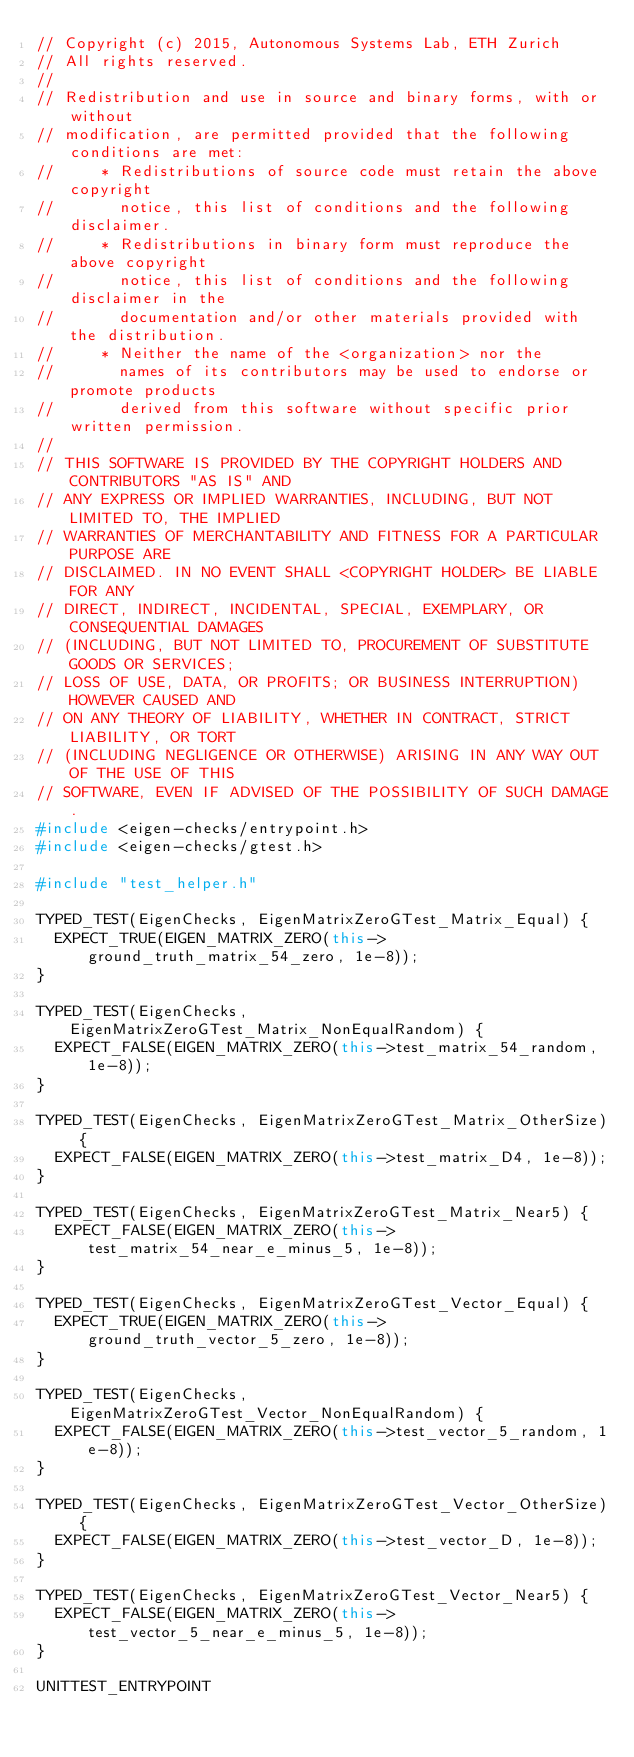Convert code to text. <code><loc_0><loc_0><loc_500><loc_500><_C++_>// Copyright (c) 2015, Autonomous Systems Lab, ETH Zurich
// All rights reserved.
//
// Redistribution and use in source and binary forms, with or without
// modification, are permitted provided that the following conditions are met:
//     * Redistributions of source code must retain the above copyright
//       notice, this list of conditions and the following disclaimer.
//     * Redistributions in binary form must reproduce the above copyright
//       notice, this list of conditions and the following disclaimer in the
//       documentation and/or other materials provided with the distribution.
//     * Neither the name of the <organization> nor the
//       names of its contributors may be used to endorse or promote products
//       derived from this software without specific prior written permission.
//
// THIS SOFTWARE IS PROVIDED BY THE COPYRIGHT HOLDERS AND CONTRIBUTORS "AS IS" AND
// ANY EXPRESS OR IMPLIED WARRANTIES, INCLUDING, BUT NOT LIMITED TO, THE IMPLIED
// WARRANTIES OF MERCHANTABILITY AND FITNESS FOR A PARTICULAR PURPOSE ARE
// DISCLAIMED. IN NO EVENT SHALL <COPYRIGHT HOLDER> BE LIABLE FOR ANY
// DIRECT, INDIRECT, INCIDENTAL, SPECIAL, EXEMPLARY, OR CONSEQUENTIAL DAMAGES
// (INCLUDING, BUT NOT LIMITED TO, PROCUREMENT OF SUBSTITUTE GOODS OR SERVICES;
// LOSS OF USE, DATA, OR PROFITS; OR BUSINESS INTERRUPTION) HOWEVER CAUSED AND
// ON ANY THEORY OF LIABILITY, WHETHER IN CONTRACT, STRICT LIABILITY, OR TORT
// (INCLUDING NEGLIGENCE OR OTHERWISE) ARISING IN ANY WAY OUT OF THE USE OF THIS
// SOFTWARE, EVEN IF ADVISED OF THE POSSIBILITY OF SUCH DAMAGE.
#include <eigen-checks/entrypoint.h>
#include <eigen-checks/gtest.h>

#include "test_helper.h"

TYPED_TEST(EigenChecks, EigenMatrixZeroGTest_Matrix_Equal) {
  EXPECT_TRUE(EIGEN_MATRIX_ZERO(this->ground_truth_matrix_54_zero, 1e-8));
}

TYPED_TEST(EigenChecks, EigenMatrixZeroGTest_Matrix_NonEqualRandom) {
  EXPECT_FALSE(EIGEN_MATRIX_ZERO(this->test_matrix_54_random, 1e-8));
}

TYPED_TEST(EigenChecks, EigenMatrixZeroGTest_Matrix_OtherSize) {
  EXPECT_FALSE(EIGEN_MATRIX_ZERO(this->test_matrix_D4, 1e-8));
}

TYPED_TEST(EigenChecks, EigenMatrixZeroGTest_Matrix_Near5) {
  EXPECT_FALSE(EIGEN_MATRIX_ZERO(this->test_matrix_54_near_e_minus_5, 1e-8));
}

TYPED_TEST(EigenChecks, EigenMatrixZeroGTest_Vector_Equal) {
  EXPECT_TRUE(EIGEN_MATRIX_ZERO(this->ground_truth_vector_5_zero, 1e-8));
}

TYPED_TEST(EigenChecks, EigenMatrixZeroGTest_Vector_NonEqualRandom) {
  EXPECT_FALSE(EIGEN_MATRIX_ZERO(this->test_vector_5_random, 1e-8));
}

TYPED_TEST(EigenChecks, EigenMatrixZeroGTest_Vector_OtherSize) {
  EXPECT_FALSE(EIGEN_MATRIX_ZERO(this->test_vector_D, 1e-8));
}

TYPED_TEST(EigenChecks, EigenMatrixZeroGTest_Vector_Near5) {
  EXPECT_FALSE(EIGEN_MATRIX_ZERO(this->test_vector_5_near_e_minus_5, 1e-8));
}

UNITTEST_ENTRYPOINT
</code> 